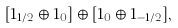<formula> <loc_0><loc_0><loc_500><loc_500>[ { 1 } _ { 1 / 2 } \oplus { 1 } _ { 0 } ] \oplus [ { 1 } _ { 0 } \oplus { 1 } _ { - 1 / 2 } ] ,</formula> 